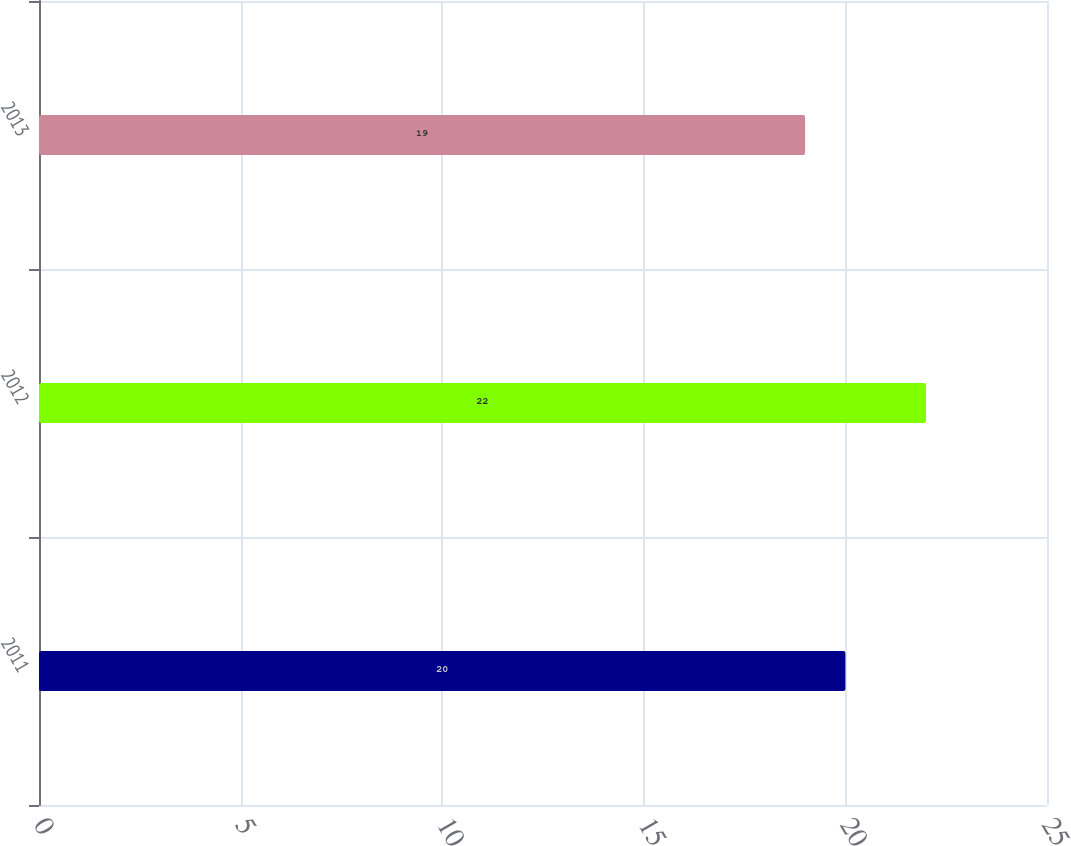<chart> <loc_0><loc_0><loc_500><loc_500><bar_chart><fcel>2011<fcel>2012<fcel>2013<nl><fcel>20<fcel>22<fcel>19<nl></chart> 